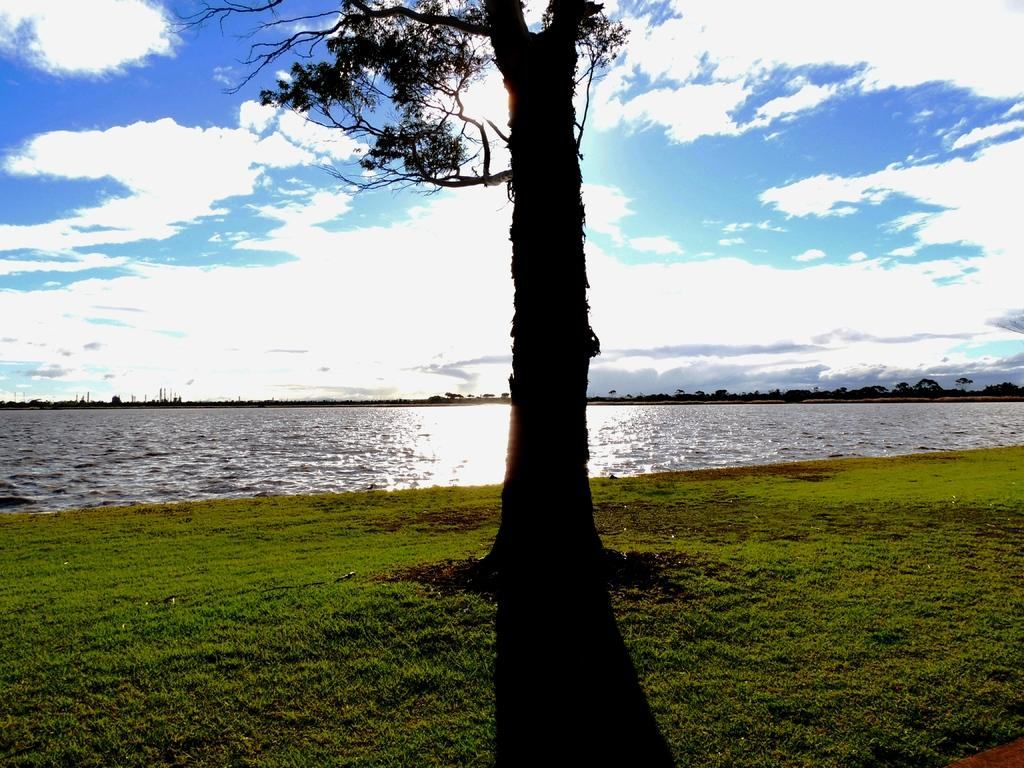What is the main object in the image? There is a tree in the image. What is the color of the ground beneath the tree? The ground beneath the tree is green. What is located beside the tree? There is water beside the tree. What can be seen in the background of the image? There are trees in the background of the image. What is the condition of the person's eye in the image? There is no person or eye present in the image; it features a tree, green ground, water, and trees in the background. 